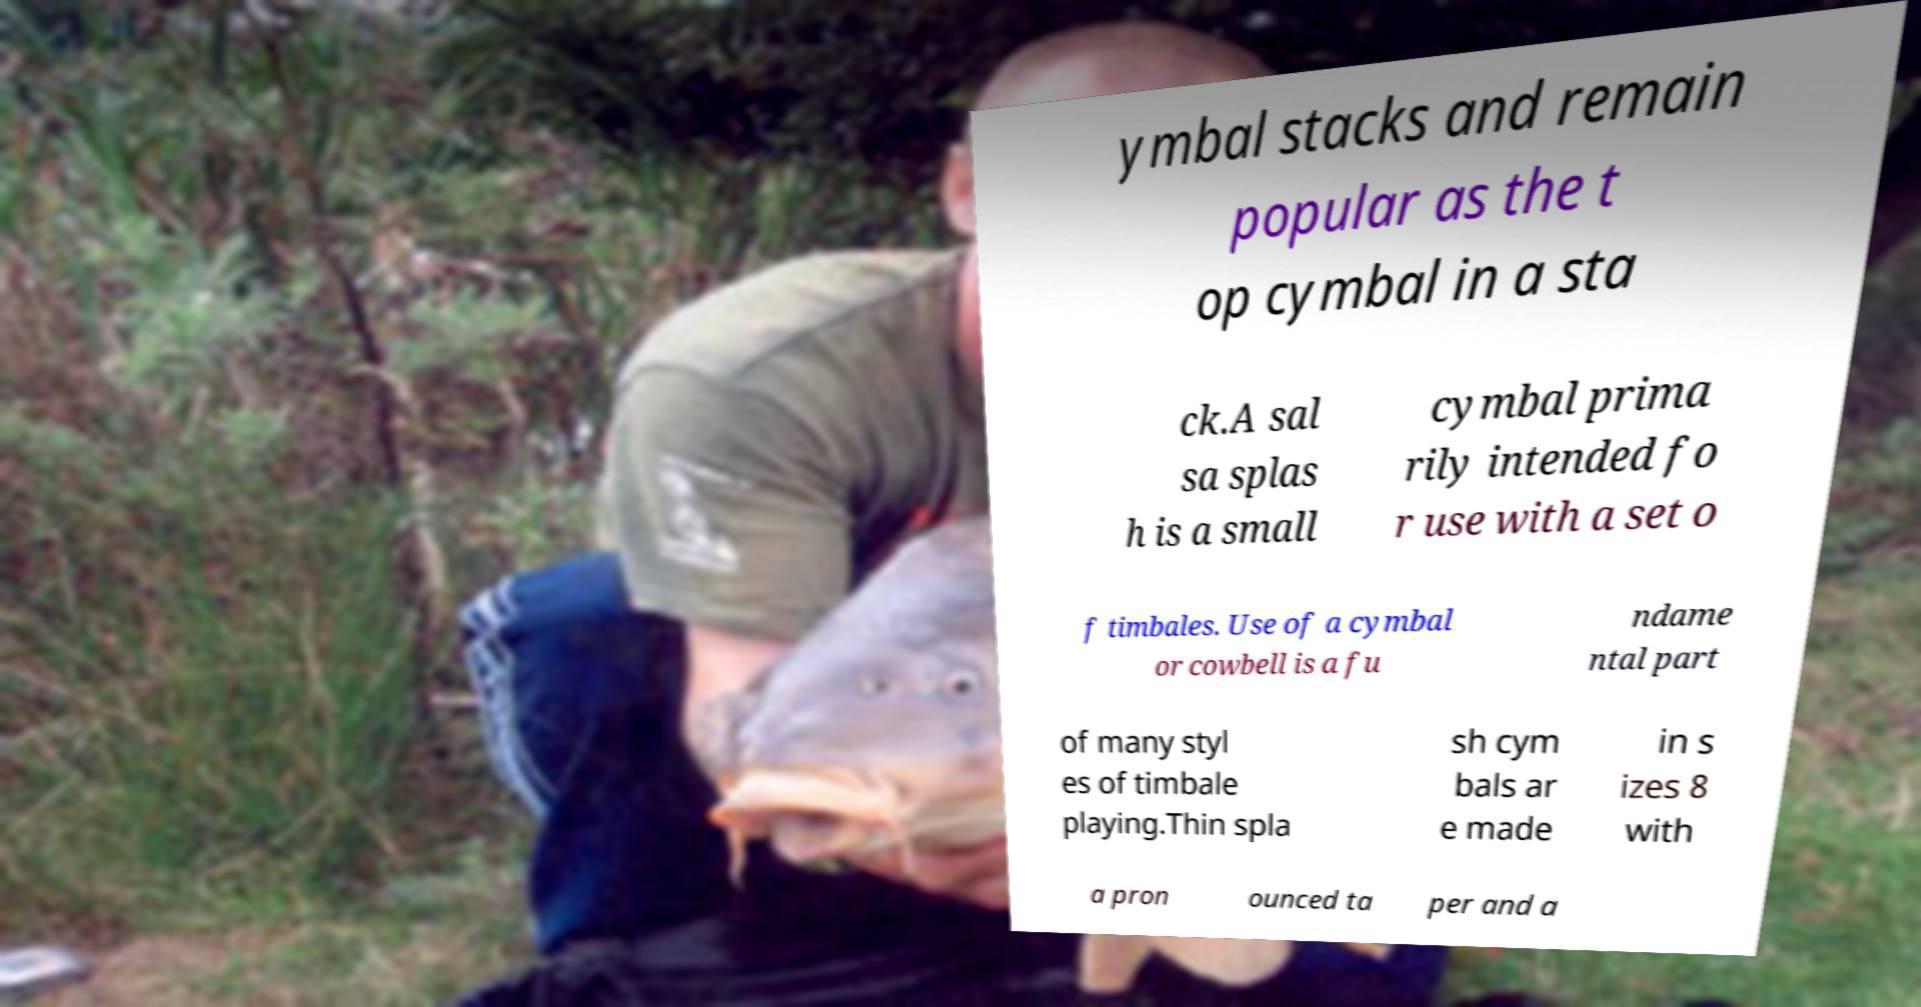Please read and relay the text visible in this image. What does it say? ymbal stacks and remain popular as the t op cymbal in a sta ck.A sal sa splas h is a small cymbal prima rily intended fo r use with a set o f timbales. Use of a cymbal or cowbell is a fu ndame ntal part of many styl es of timbale playing.Thin spla sh cym bals ar e made in s izes 8 with a pron ounced ta per and a 